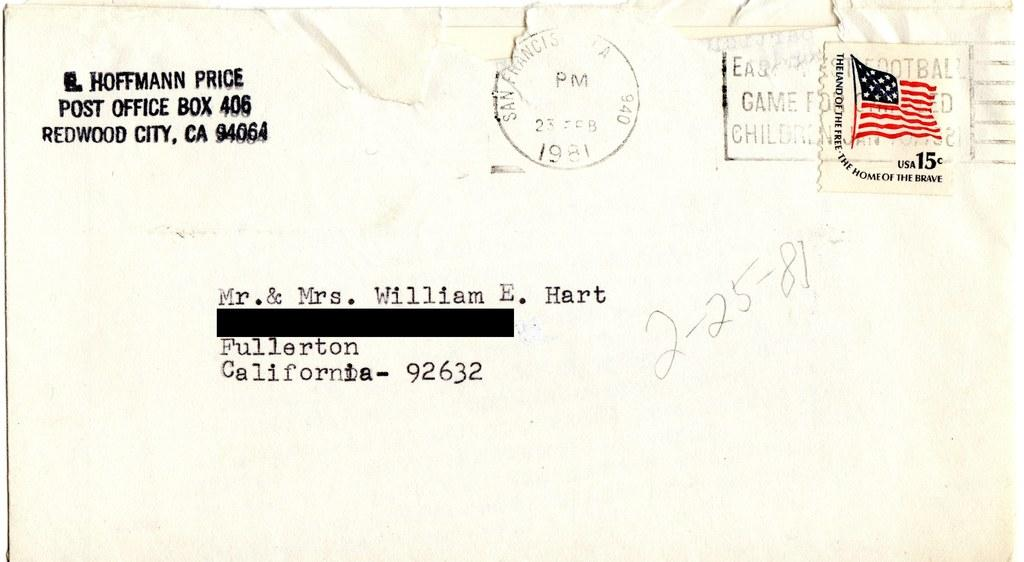<image>
Offer a succinct explanation of the picture presented. A letter addressed to Mr. & Mrs. William E. Hart in Fullerton California. 